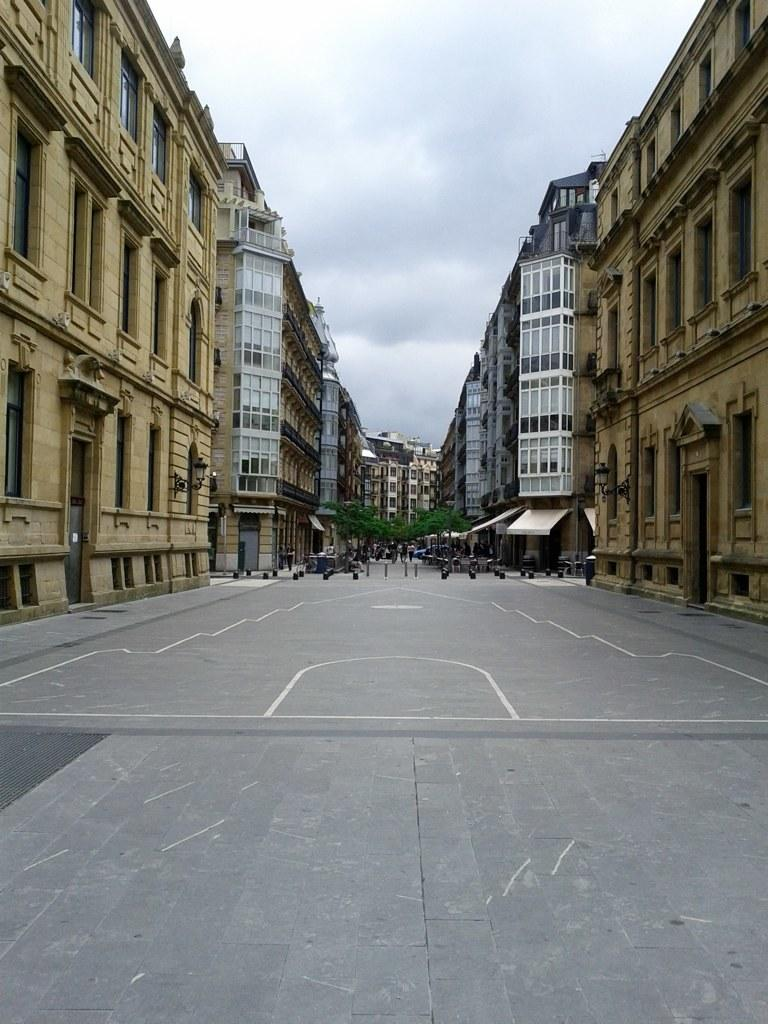What is the main feature of the image? There is a road in the image. What can be seen on both sides of the road? There are buildings and footpaths on both sides of the road. What is visible in the background of the image? There are trees and persons in the background of the image, as well as clouds visible in the sky. How many friends are playing with the dogs in the image? There are no friends or dogs present in the image; it features a road with buildings, footpaths, trees, persons, and clouds visible in the sky. 